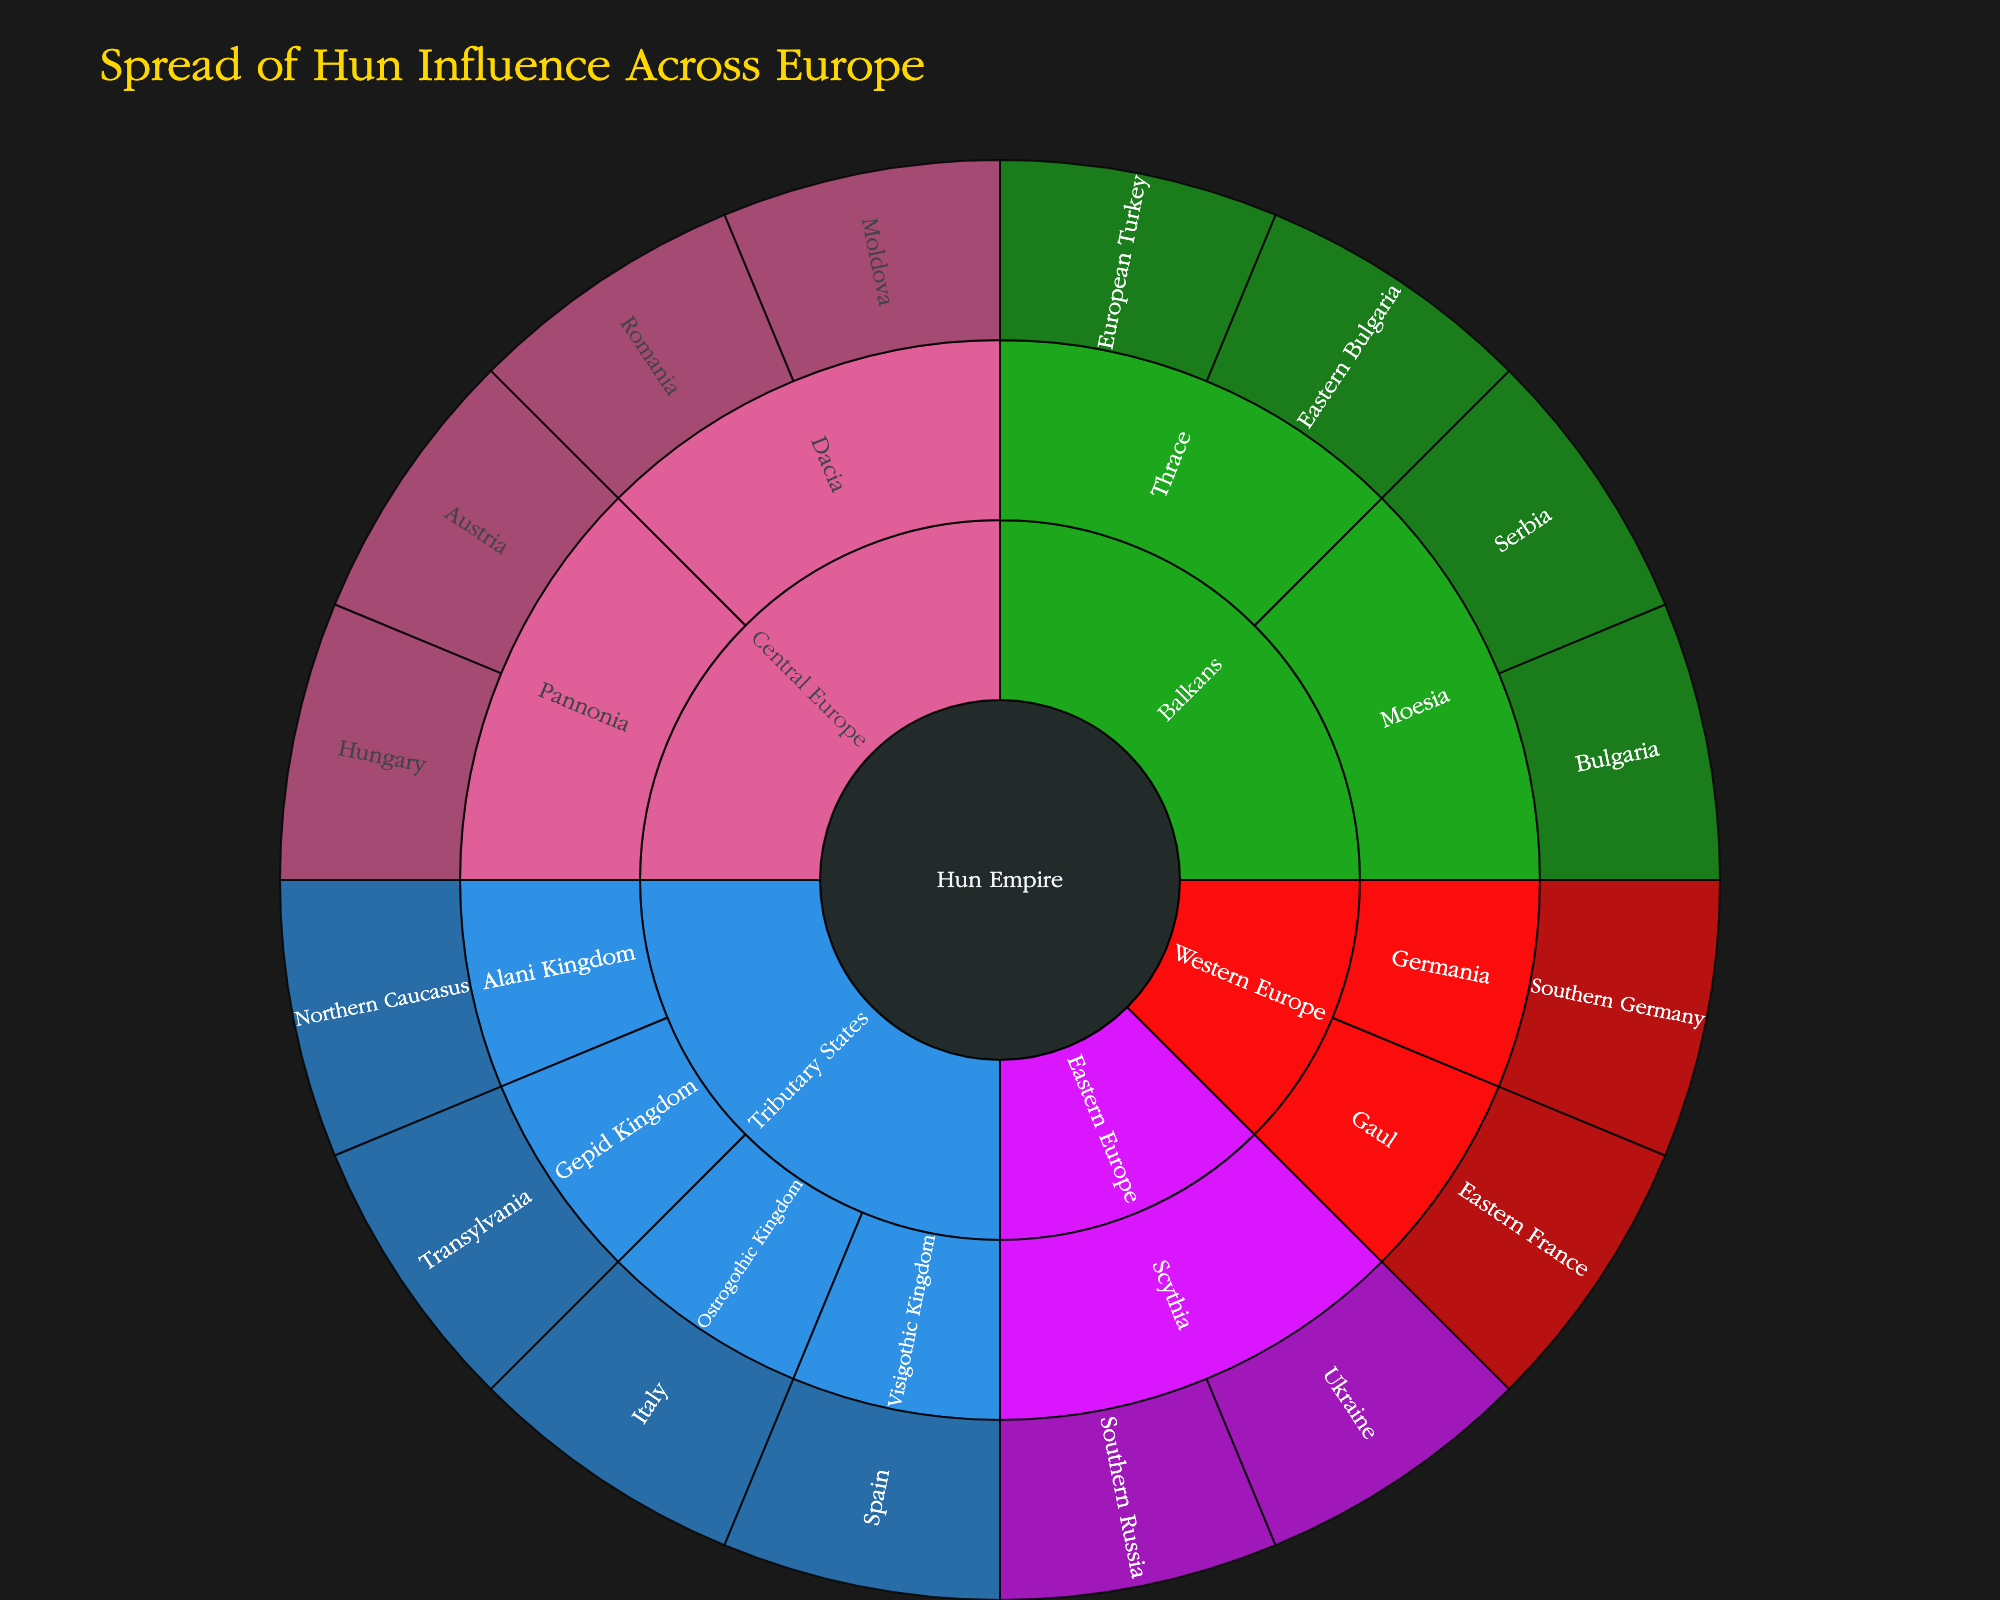What is the title of the Sunburst plot? The title of the Sunburst plot is typically displayed at the top of the figure. It serves to provide the viewer with an immediate understanding of the subject of the visualization. In this case, the title is 'Spread of Hun Influence Across Europe'.
Answer: 'Spread of Hun Influence Across Europe' Which region contains the subregion Pannonia? To find the region of a specific subregion, look at the structure of the plot. Pannonia is part of the Central Europe region according to the data.
Answer: Central Europe How many territories fall under the Western Europe region? To find the number of territories within Western Europe, count each leaf node within the Western Europe section of the Sunburst plot. According to the data, there are two subregions (Gaul and Germania), and each has one territory (Eastern France in Gaul and Southern Germany in Germania). Therefore, there are 2 territories.
Answer: 2 What are the territories listed under the Balkans region? To determine which territories are in the Balkans, identify the subregions within the Balkans segment of the plot, and then note the territories within those subregions. The subregions and their territories are: Moesia (Bulgaria, Serbia) and Thrace (Eastern Bulgaria, European Turkey).
Answer: Bulgaria, Serbia, Eastern Bulgaria, European Turkey Which region has the most subregions and how many does it have? To find the region with the most subregions, count the subregions within each region. According to the data, Central Europe has two subregions (Pannonia and Dacia), Eastern Europe has one (Scythia), the Balkans have two (Moesia and Thrace), Western Europe has two (Gaul and Germania), and Tributary States have four (Ostrogothic Kingdom, Visigothic Kingdom, Alani Kingdom, Gepid Kingdom). Tributary States has the most subregions with four.
Answer: Tributary States; 4 Which region appears the smallest procedurally in the plot? Visually inspect the Sunburst plot for the region with the smallest segment area, indicating fewer subdivisions or territories. Reference data confirms that Eastern Europe appears smallest with only two territories (Ukraine, Southern Russia) under one subregion (Scythia).
Answer: Eastern Europe How many territories across all regions formed the Hun Empire? Sum all territories listed across each region in the Hun Empire: Pannonia (2), Dacia (2), Scythia (2), Moesia (2), Thrace (2), Gaul (1), Germania (1), Ostrogothic Kingdom (1), Visigothic Kingdom (1), Alani Kingdom (1), Gepid Kingdom (1). Totaling all these gives (2+2+2+2+2+1+1+1+1+1+1) = 16 territories.
Answer: 16 Which territories are part of the Central Europe region under the Hun Empire? Identify territories under each subregion within Central Europe section of the data and plot. Central Europe includes Pannonia (Hungary, Austria) and Dacia (Romania, Moldova).
Answer: Hungary, Austria, Romania, Moldova How does the distribution of territories differ between Eastern and Western Europe regions? Compare the number and diversity of territories. Eastern Europe has two territories within one subregion (Scythia: Ukraine, Southern Russia). Western Europe, however, has two territories divided into two subregions (Gaul: Eastern France, Germania: Southern Germany). Although both have two territories, Western Europe is divided across more subregions.
Answer: Eastern and Western Europe both have two territories, but Western Europe's territories are in two subregions 